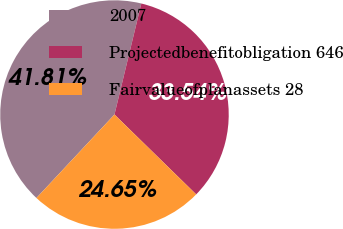Convert chart. <chart><loc_0><loc_0><loc_500><loc_500><pie_chart><fcel>2007<fcel>Projectedbenefitobligation 646<fcel>Fairvalueofplanassets 28<nl><fcel>41.81%<fcel>33.54%<fcel>24.65%<nl></chart> 